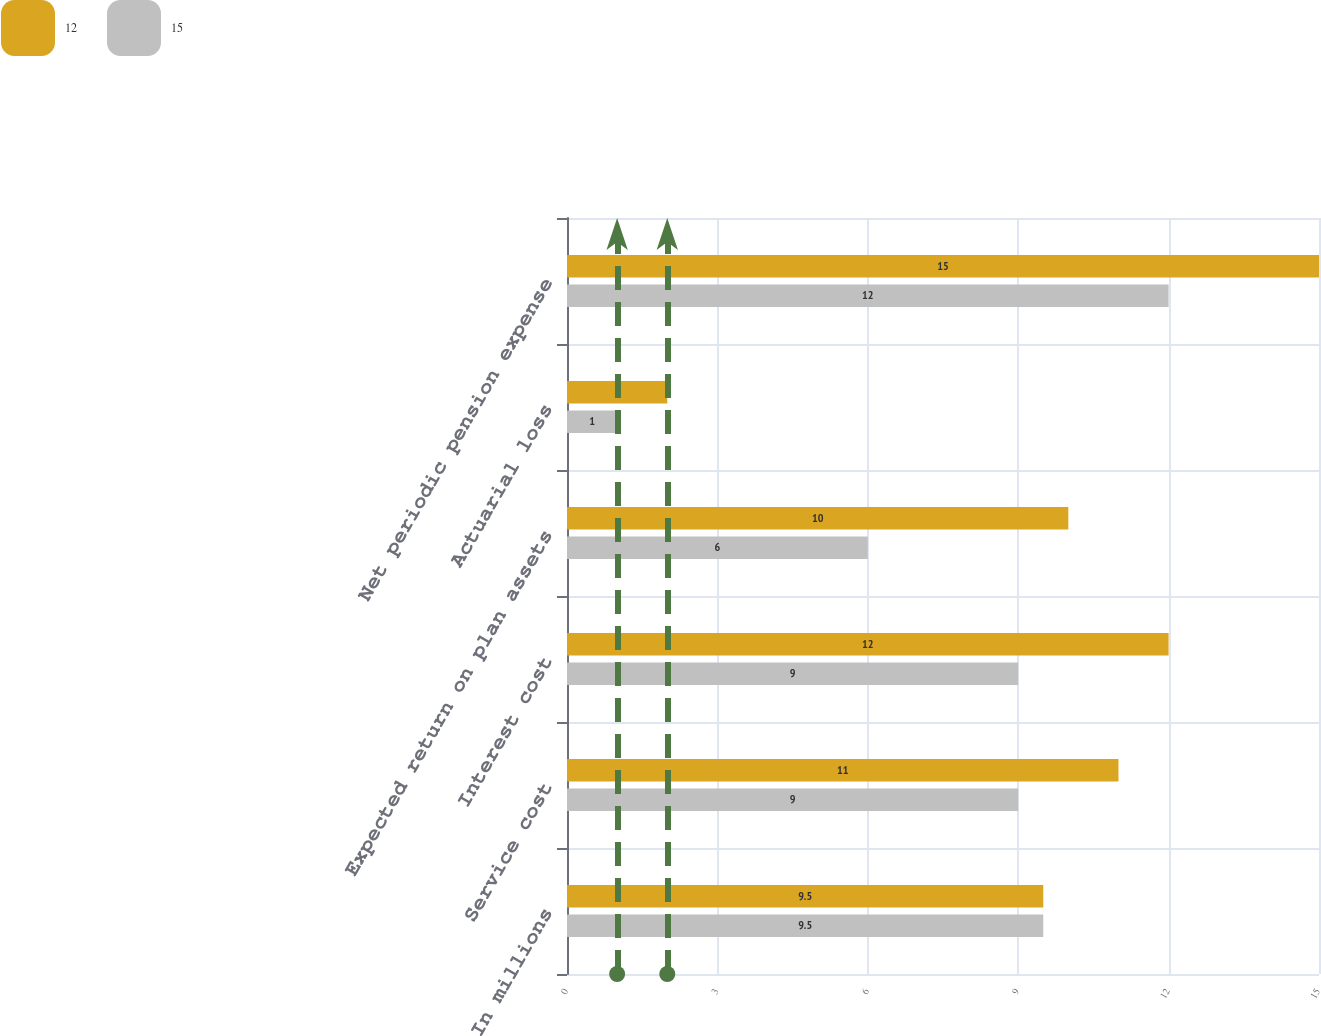Convert chart. <chart><loc_0><loc_0><loc_500><loc_500><stacked_bar_chart><ecel><fcel>In millions<fcel>Service cost<fcel>Interest cost<fcel>Expected return on plan assets<fcel>Actuarial loss<fcel>Net periodic pension expense<nl><fcel>12<fcel>9.5<fcel>11<fcel>12<fcel>10<fcel>2<fcel>15<nl><fcel>15<fcel>9.5<fcel>9<fcel>9<fcel>6<fcel>1<fcel>12<nl></chart> 